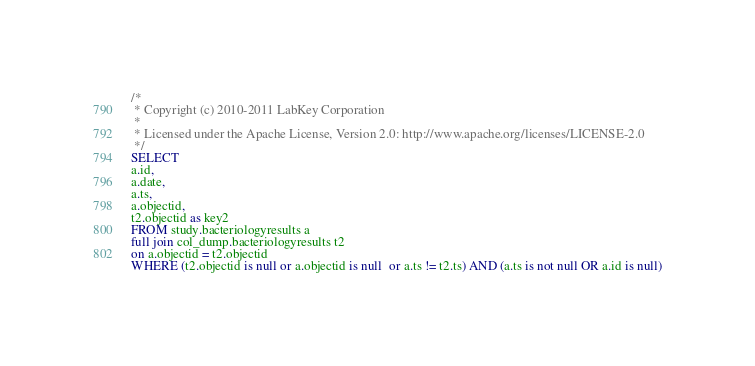<code> <loc_0><loc_0><loc_500><loc_500><_SQL_>/*
 * Copyright (c) 2010-2011 LabKey Corporation
 *
 * Licensed under the Apache License, Version 2.0: http://www.apache.org/licenses/LICENSE-2.0
 */
SELECT
a.id,
a.date,
a.ts,
a.objectid,
t2.objectid as key2
FROM study.bacteriologyresults a
full join col_dump.bacteriologyresults t2
on a.objectid = t2.objectid
WHERE (t2.objectid is null or a.objectid is null  or a.ts != t2.ts) AND (a.ts is not null OR a.id is null)</code> 